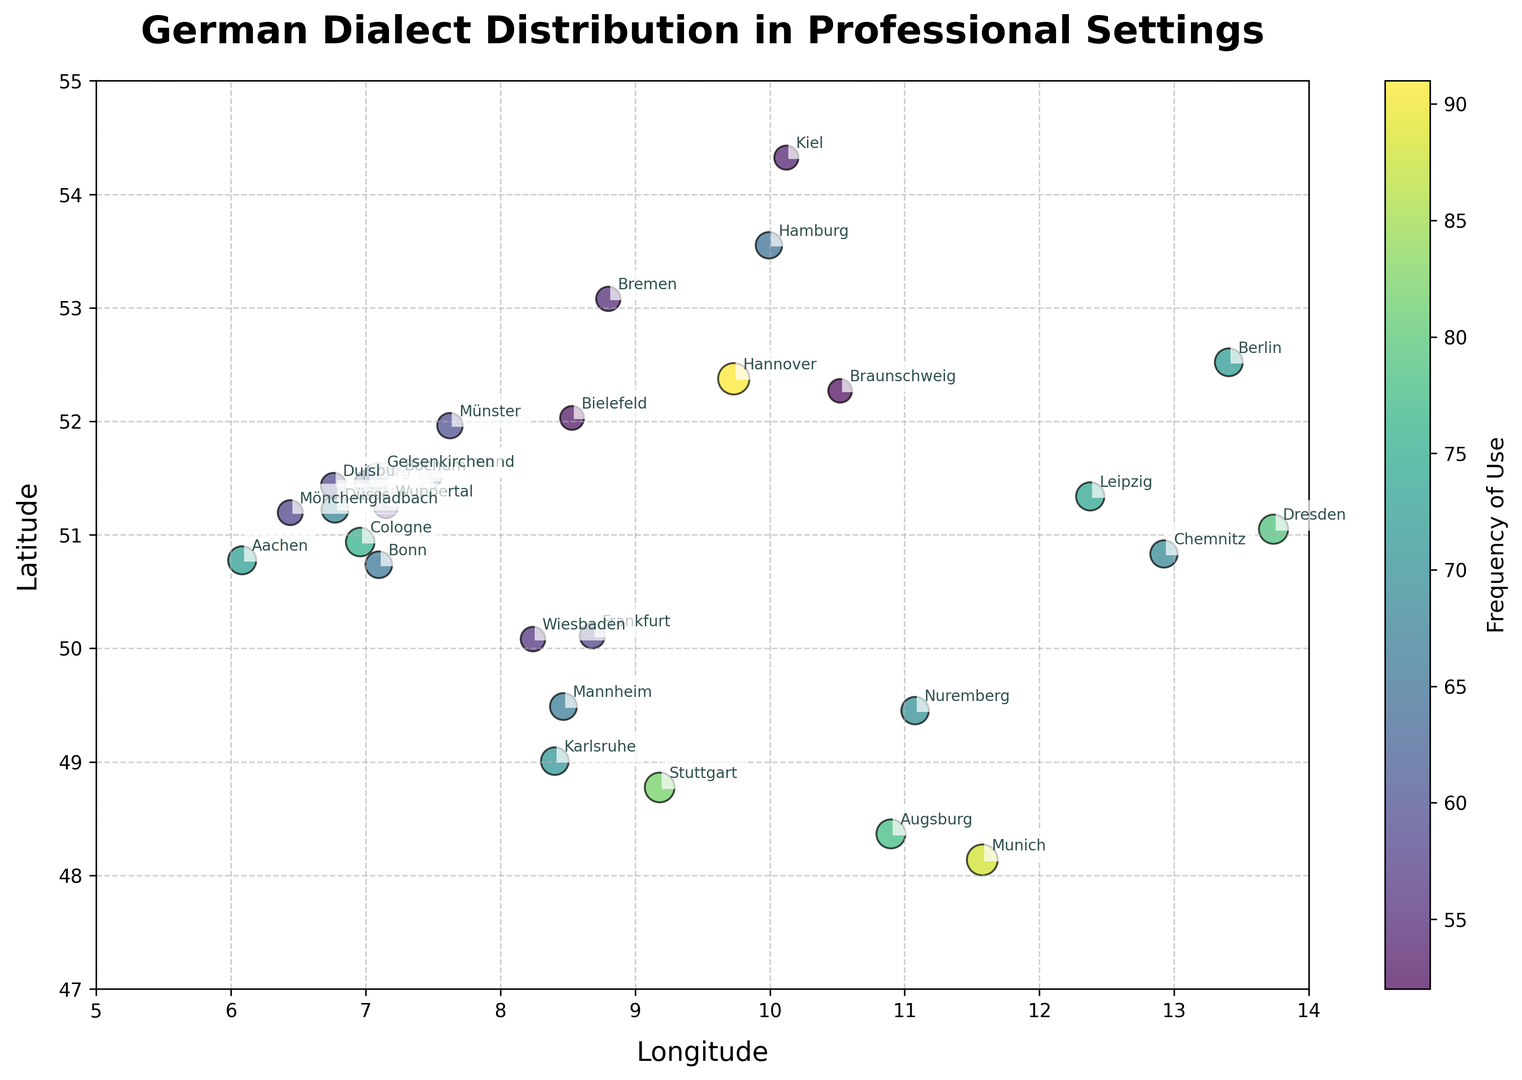Which region has the highest frequency of dialect use in professional settings? The scatter plot indicates that Hannover has the highest frequency of dialect use, marked by the largest and darkest-colored circle.
Answer: Hannover Which cities use the Schwäbisch dialect in professional settings and what are their respective frequencies? The scatter plot shows two cities using the Schwäbisch dialect: Stuttgart and Augsburg, with frequencies 82 and 78 respectively.
Answer: Stuttgart (82), Augsburg (78) What is the average frequency of dialect use for cities that have frequencies higher than 70? First, identify the cities with frequencies higher than 70: Berlinisch (72), Bairisch (88), Kölsch (76), Schwäbisch (82), Sächsisch (79), Obersächsisch (74), Niederrheinisch (73). The average is calculated as (72 + 88 + 76 + 82 + 79 + 74 + 73) / 7.
Answer: 77.71 Which dialect is represented with the darkest color on the plot, and what does this indicate about its usage frequency? The darkest color corresponds to the Standarddeutsch dialect in Hannover, indicating the highest usage frequency of 91.
Answer: Standarddeutsch (Hannover) Compare the frequency of dialect use in Cologne and Düsseldorf. Which city uses its respective dialect more frequently in professional settings? The plot shows that Cologne (Kölsch - 76) has a higher usage frequency than Düsseldorf (Rheinisch - 68).
Answer: Cologne What is the combined frequency of dialect use for all Ruhrdeutsch-speaking cities? Identify Ruhrdeutsch-speaking cities: Dortmund, Essen, Bochum, Gelsenkirchen with frequencies of 63, 61, 62, and 64 respectively. The combined frequency is 63 + 61 + 62 + 64.
Answer: 250 Which region is positioned at the northernmost latitude, and what is its corresponding dialect and usage frequency? The region at the northernmost latitude on the plot is Hamburg, using Hamburgisch dialect with a frequency of 65.
Answer: Hamburg (Hamburgisch, 65) How does the frequency of use for Rheinisch in both Düsseldorf and Bonn compare? Rheinisch is used in Düsseldorf and Bonn with frequencies of 68 and 66 respectively.
Answer: Düsseldorf (68) > Bonn (66) What is the average frequency of dialects used in professional settings in cities located above 51 degrees latitude? Cities above 51 degrees latitude: Hamburg, Berlin, Hannover, Dresden, Leipzig, Dortmund, Essen, Duisburg, Bochum, Wuppertal, Bielefeld, Gelsenkirchen, Mönchengladbach, Braunschweig (frequencies: 65, 72, 91, 79, 74, 63, 61, 59, 62, 57, 53, 64, 58, 52). Average is calculated as (65+72+91+79+74+63+61+59+62+57+53+64+58+52) / 14.
Answer: 65.71 